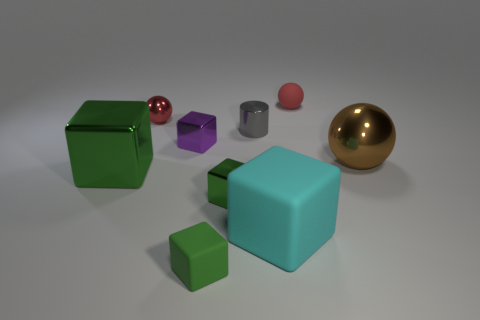Subtract all gray balls. How many green cubes are left? 3 Subtract all purple blocks. How many blocks are left? 4 Subtract all large metallic blocks. How many blocks are left? 4 Subtract all red cubes. Subtract all cyan cylinders. How many cubes are left? 5 Subtract all balls. How many objects are left? 6 Add 9 small purple rubber cylinders. How many small purple rubber cylinders exist? 9 Subtract 0 yellow blocks. How many objects are left? 9 Subtract all big red metallic blocks. Subtract all small rubber objects. How many objects are left? 7 Add 9 tiny purple metallic cubes. How many tiny purple metallic cubes are left? 10 